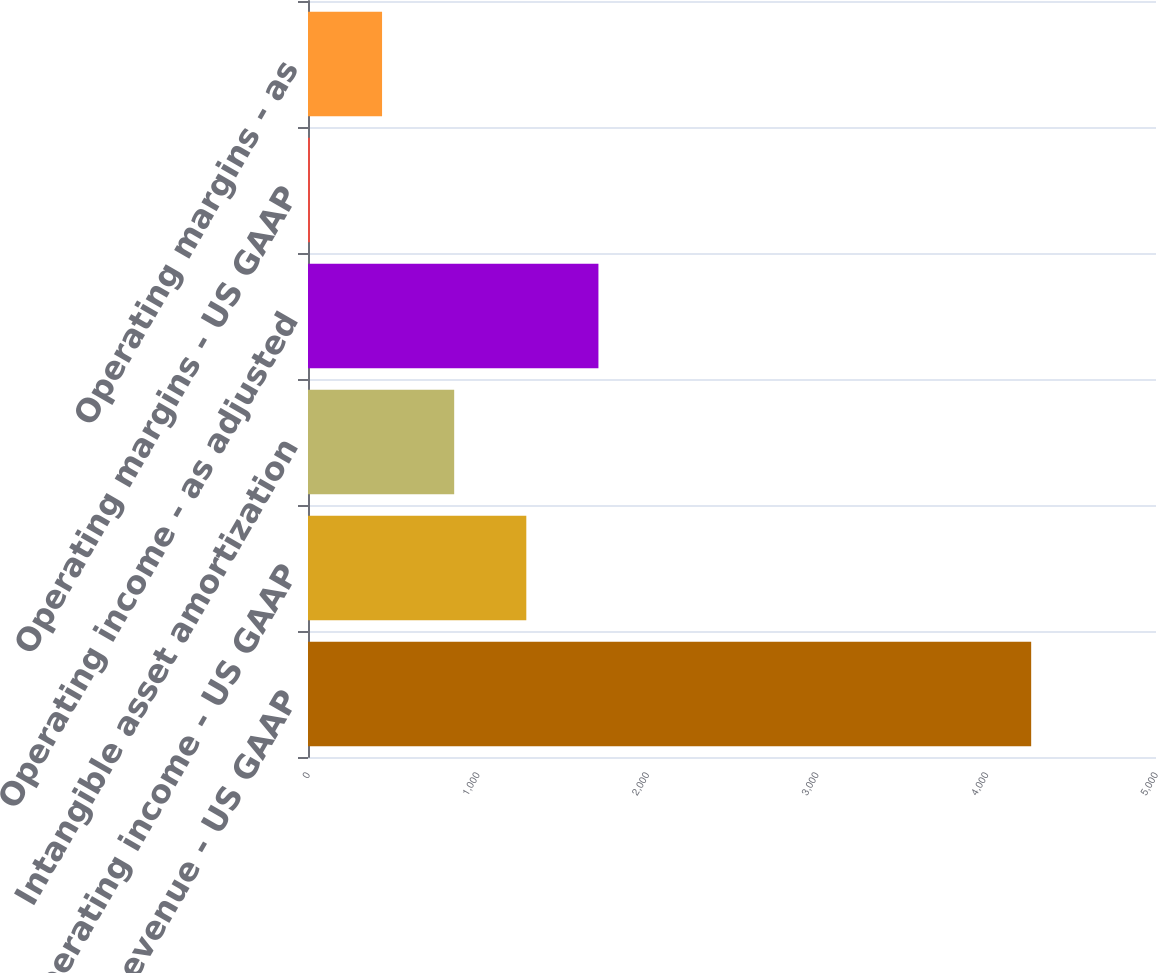Convert chart. <chart><loc_0><loc_0><loc_500><loc_500><bar_chart><fcel>Revenue - US GAAP<fcel>Operating income - US GAAP<fcel>Intangible asset amortization<fcel>Operating income - as adjusted<fcel>Operating margins - US GAAP<fcel>Operating margins - as<nl><fcel>4264<fcel>1287.18<fcel>861.92<fcel>1712.44<fcel>11.4<fcel>436.66<nl></chart> 